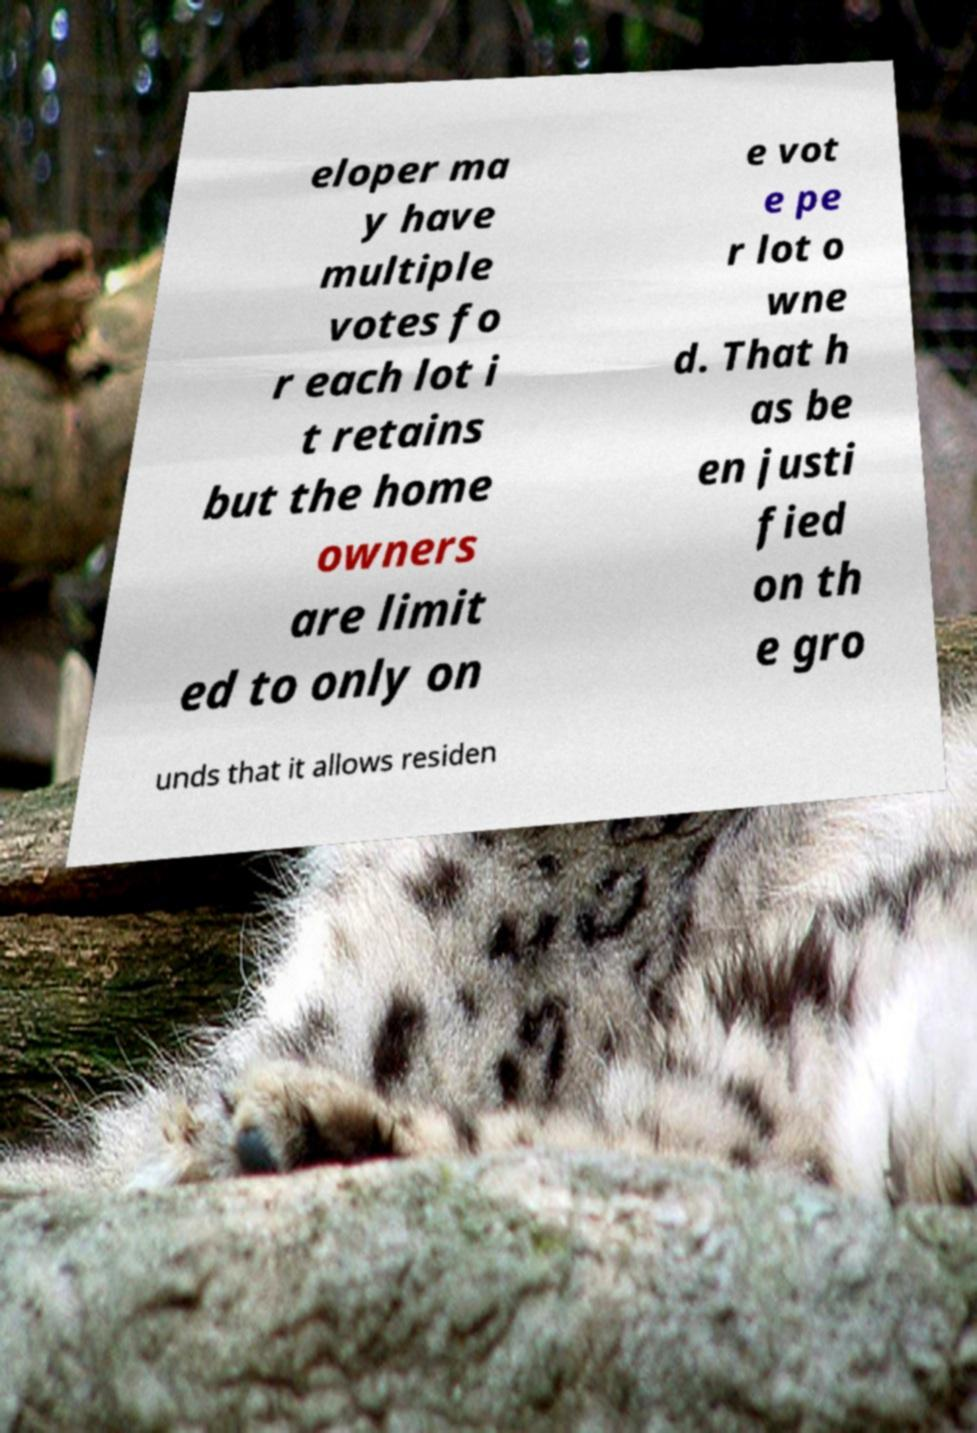Could you extract and type out the text from this image? eloper ma y have multiple votes fo r each lot i t retains but the home owners are limit ed to only on e vot e pe r lot o wne d. That h as be en justi fied on th e gro unds that it allows residen 